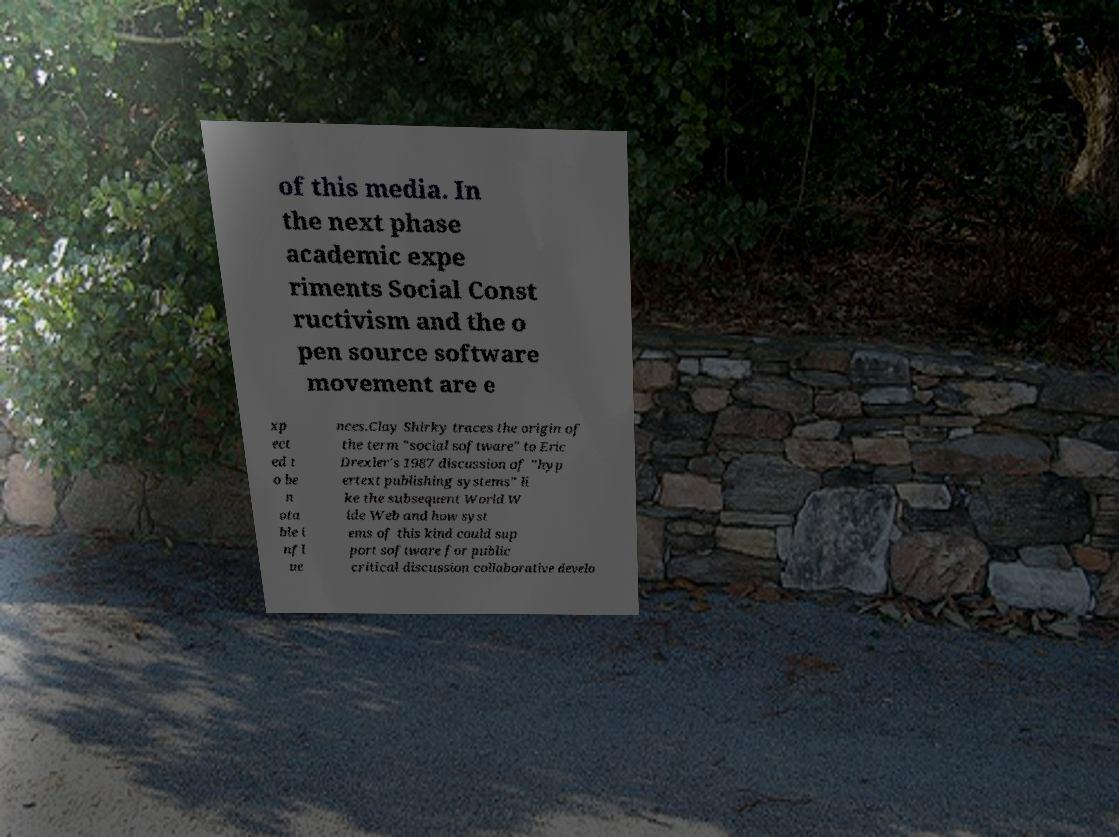Please identify and transcribe the text found in this image. of this media. In the next phase academic expe riments Social Const ructivism and the o pen source software movement are e xp ect ed t o be n ota ble i nfl ue nces.Clay Shirky traces the origin of the term "social software" to Eric Drexler's 1987 discussion of "hyp ertext publishing systems" li ke the subsequent World W ide Web and how syst ems of this kind could sup port software for public critical discussion collaborative develo 